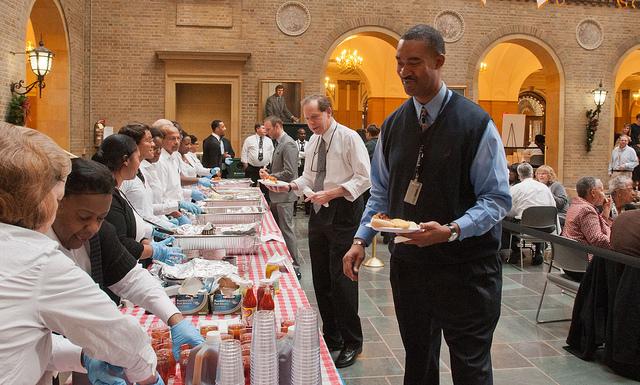Do you feel shy at a large party?
Write a very short answer. Yes. Is the man in front frowning or smiling?
Short answer required. Smiling. Is anyone wearing a tie?
Keep it brief. Yes. 